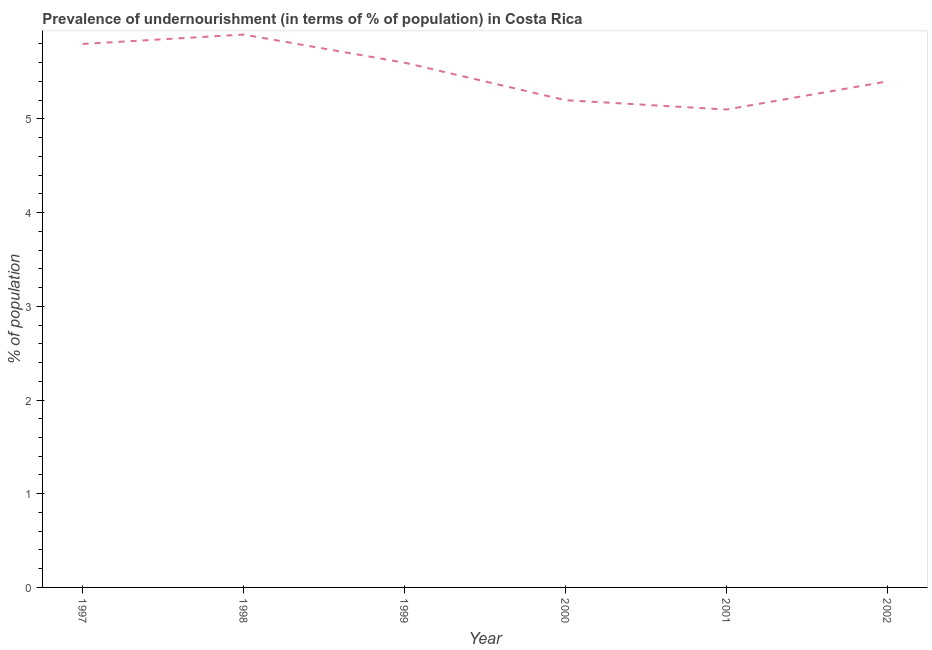In which year was the percentage of undernourished population maximum?
Your answer should be very brief. 1998. What is the sum of the percentage of undernourished population?
Offer a very short reply. 33. What is the difference between the percentage of undernourished population in 2000 and 2001?
Provide a short and direct response. 0.1. What is the average percentage of undernourished population per year?
Provide a succinct answer. 5.5. Do a majority of the years between 1999 and 2000 (inclusive) have percentage of undernourished population greater than 5.4 %?
Offer a terse response. No. What is the ratio of the percentage of undernourished population in 1998 to that in 2001?
Your response must be concise. 1.16. What is the difference between the highest and the second highest percentage of undernourished population?
Offer a very short reply. 0.1. Is the sum of the percentage of undernourished population in 1999 and 2000 greater than the maximum percentage of undernourished population across all years?
Make the answer very short. Yes. What is the difference between the highest and the lowest percentage of undernourished population?
Make the answer very short. 0.8. How many lines are there?
Ensure brevity in your answer.  1. Are the values on the major ticks of Y-axis written in scientific E-notation?
Keep it short and to the point. No. Does the graph contain any zero values?
Your answer should be very brief. No. What is the title of the graph?
Your answer should be very brief. Prevalence of undernourishment (in terms of % of population) in Costa Rica. What is the label or title of the X-axis?
Offer a terse response. Year. What is the label or title of the Y-axis?
Your answer should be compact. % of population. What is the % of population in 1997?
Your answer should be compact. 5.8. What is the % of population in 1998?
Your answer should be very brief. 5.9. What is the % of population in 2001?
Offer a terse response. 5.1. What is the difference between the % of population in 1997 and 1999?
Give a very brief answer. 0.2. What is the difference between the % of population in 1997 and 2001?
Offer a terse response. 0.7. What is the difference between the % of population in 1999 and 2000?
Provide a short and direct response. 0.4. What is the difference between the % of population in 1999 and 2002?
Ensure brevity in your answer.  0.2. What is the difference between the % of population in 2000 and 2001?
Give a very brief answer. 0.1. What is the difference between the % of population in 2000 and 2002?
Your answer should be very brief. -0.2. What is the difference between the % of population in 2001 and 2002?
Provide a short and direct response. -0.3. What is the ratio of the % of population in 1997 to that in 1999?
Offer a terse response. 1.04. What is the ratio of the % of population in 1997 to that in 2000?
Offer a very short reply. 1.11. What is the ratio of the % of population in 1997 to that in 2001?
Ensure brevity in your answer.  1.14. What is the ratio of the % of population in 1997 to that in 2002?
Make the answer very short. 1.07. What is the ratio of the % of population in 1998 to that in 1999?
Provide a succinct answer. 1.05. What is the ratio of the % of population in 1998 to that in 2000?
Ensure brevity in your answer.  1.14. What is the ratio of the % of population in 1998 to that in 2001?
Keep it short and to the point. 1.16. What is the ratio of the % of population in 1998 to that in 2002?
Offer a terse response. 1.09. What is the ratio of the % of population in 1999 to that in 2000?
Offer a terse response. 1.08. What is the ratio of the % of population in 1999 to that in 2001?
Offer a very short reply. 1.1. What is the ratio of the % of population in 2001 to that in 2002?
Keep it short and to the point. 0.94. 